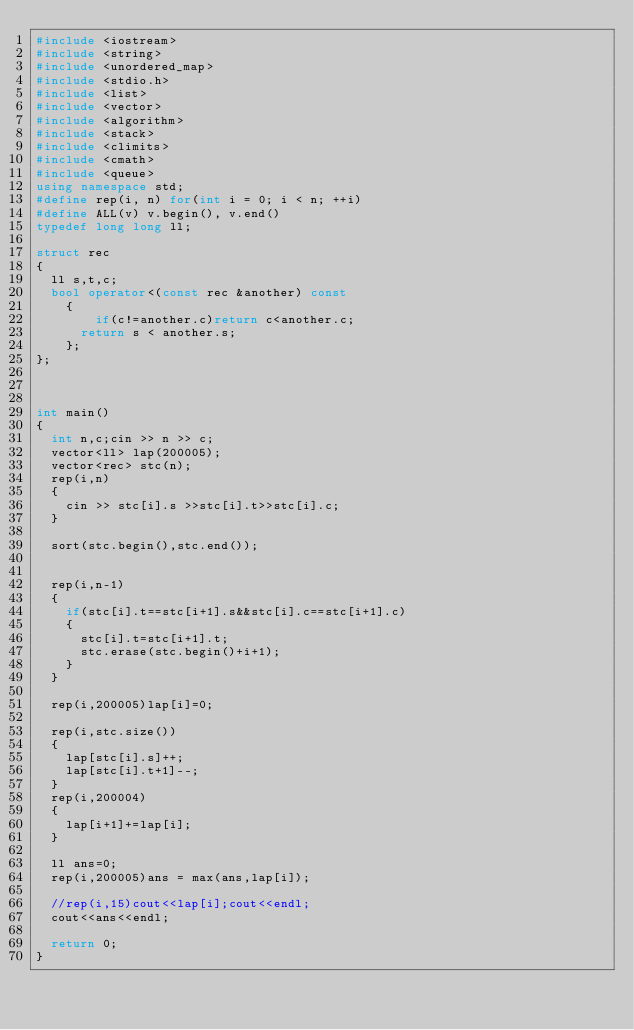Convert code to text. <code><loc_0><loc_0><loc_500><loc_500><_C++_>#include <iostream>
#include <string>
#include <unordered_map>
#include <stdio.h>
#include <list>
#include <vector>
#include <algorithm>
#include <stack>
#include <climits>
#include <cmath>
#include <queue>
using namespace std;
#define rep(i, n) for(int i = 0; i < n; ++i)
#define ALL(v) v.begin(), v.end()
typedef long long ll;

struct rec
{
	ll s,t,c;
	bool operator<(const rec &another) const
    {
        if(c!=another.c)return c<another.c;
		  return s < another.s;
    };
};



int main()
{
	int n,c;cin >> n >> c;
	vector<ll> lap(200005);
	vector<rec> stc(n);
	rep(i,n)
	{
		cin >> stc[i].s >>stc[i].t>>stc[i].c;
	}

	sort(stc.begin(),stc.end());


	rep(i,n-1)
	{
		if(stc[i].t==stc[i+1].s&&stc[i].c==stc[i+1].c)
		{
			stc[i].t=stc[i+1].t;
			stc.erase(stc.begin()+i+1);
		}
	}

	rep(i,200005)lap[i]=0;

	rep(i,stc.size())
	{
		lap[stc[i].s]++;
		lap[stc[i].t+1]--;
	}
	rep(i,200004)
	{
		lap[i+1]+=lap[i];
	}

	ll ans=0;
	rep(i,200005)ans = max(ans,lap[i]);

	//rep(i,15)cout<<lap[i];cout<<endl;
	cout<<ans<<endl;

	return 0;
}</code> 